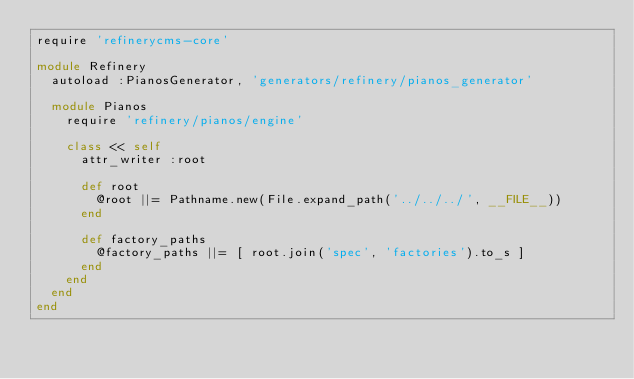<code> <loc_0><loc_0><loc_500><loc_500><_Ruby_>require 'refinerycms-core'

module Refinery
  autoload :PianosGenerator, 'generators/refinery/pianos_generator'

  module Pianos
    require 'refinery/pianos/engine'

    class << self
      attr_writer :root

      def root
        @root ||= Pathname.new(File.expand_path('../../../', __FILE__))
      end

      def factory_paths
        @factory_paths ||= [ root.join('spec', 'factories').to_s ]
      end
    end
  end
end
</code> 